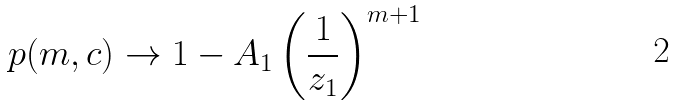Convert formula to latex. <formula><loc_0><loc_0><loc_500><loc_500>p ( m , { c } ) \rightarrow 1 - A _ { 1 } \left ( \frac { 1 } { z _ { 1 } } \right ) ^ { m + 1 }</formula> 